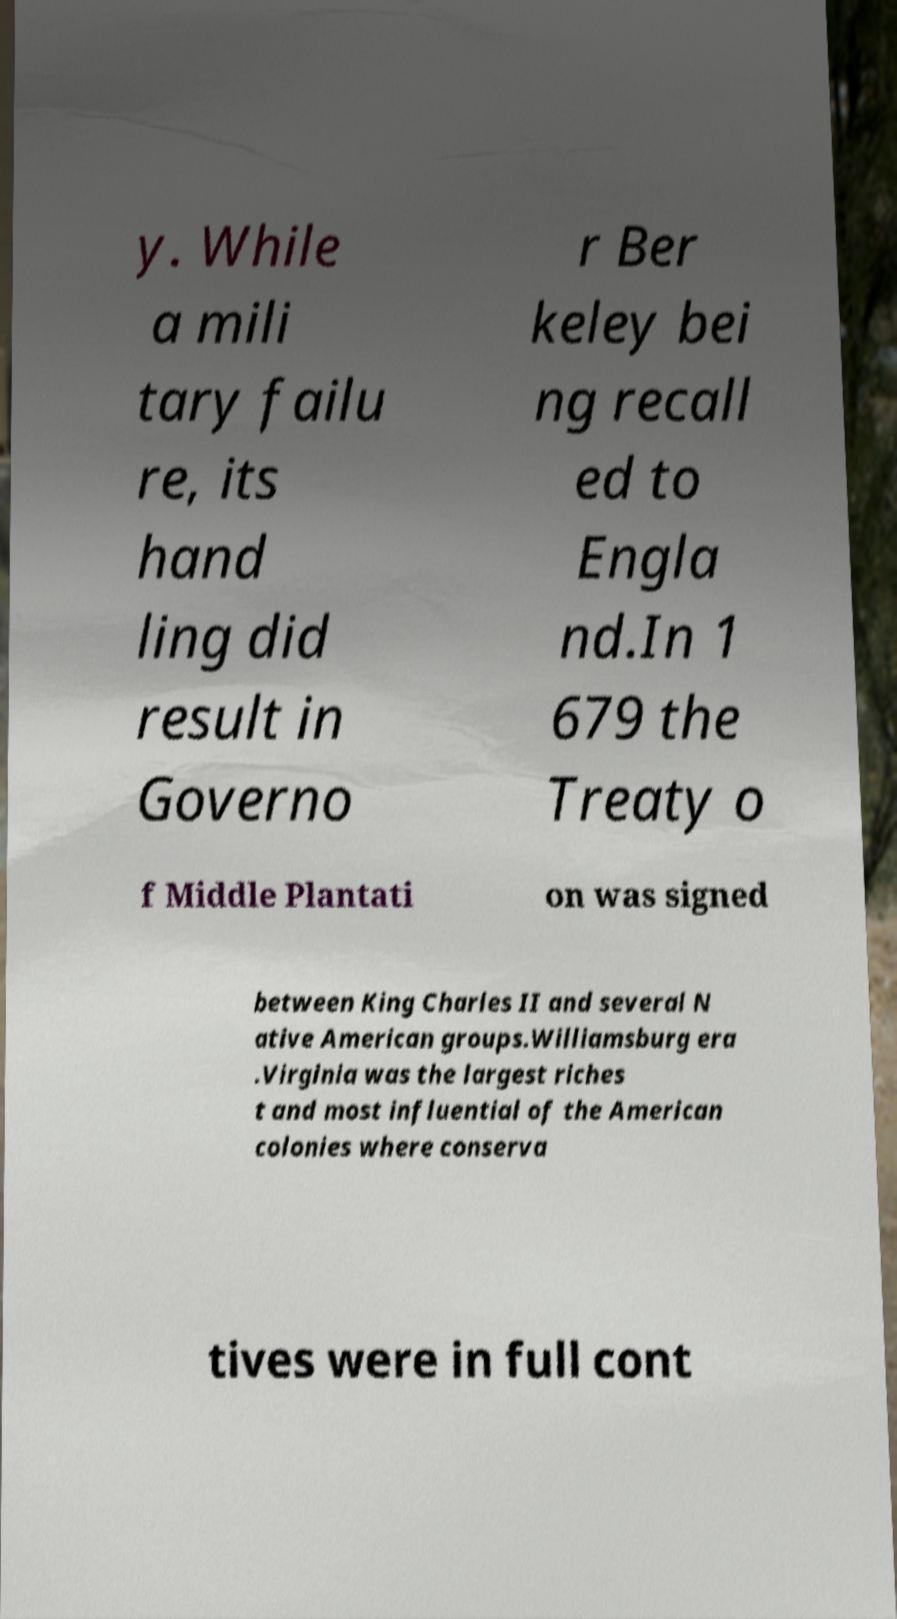Please identify and transcribe the text found in this image. y. While a mili tary failu re, its hand ling did result in Governo r Ber keley bei ng recall ed to Engla nd.In 1 679 the Treaty o f Middle Plantati on was signed between King Charles II and several N ative American groups.Williamsburg era .Virginia was the largest riches t and most influential of the American colonies where conserva tives were in full cont 